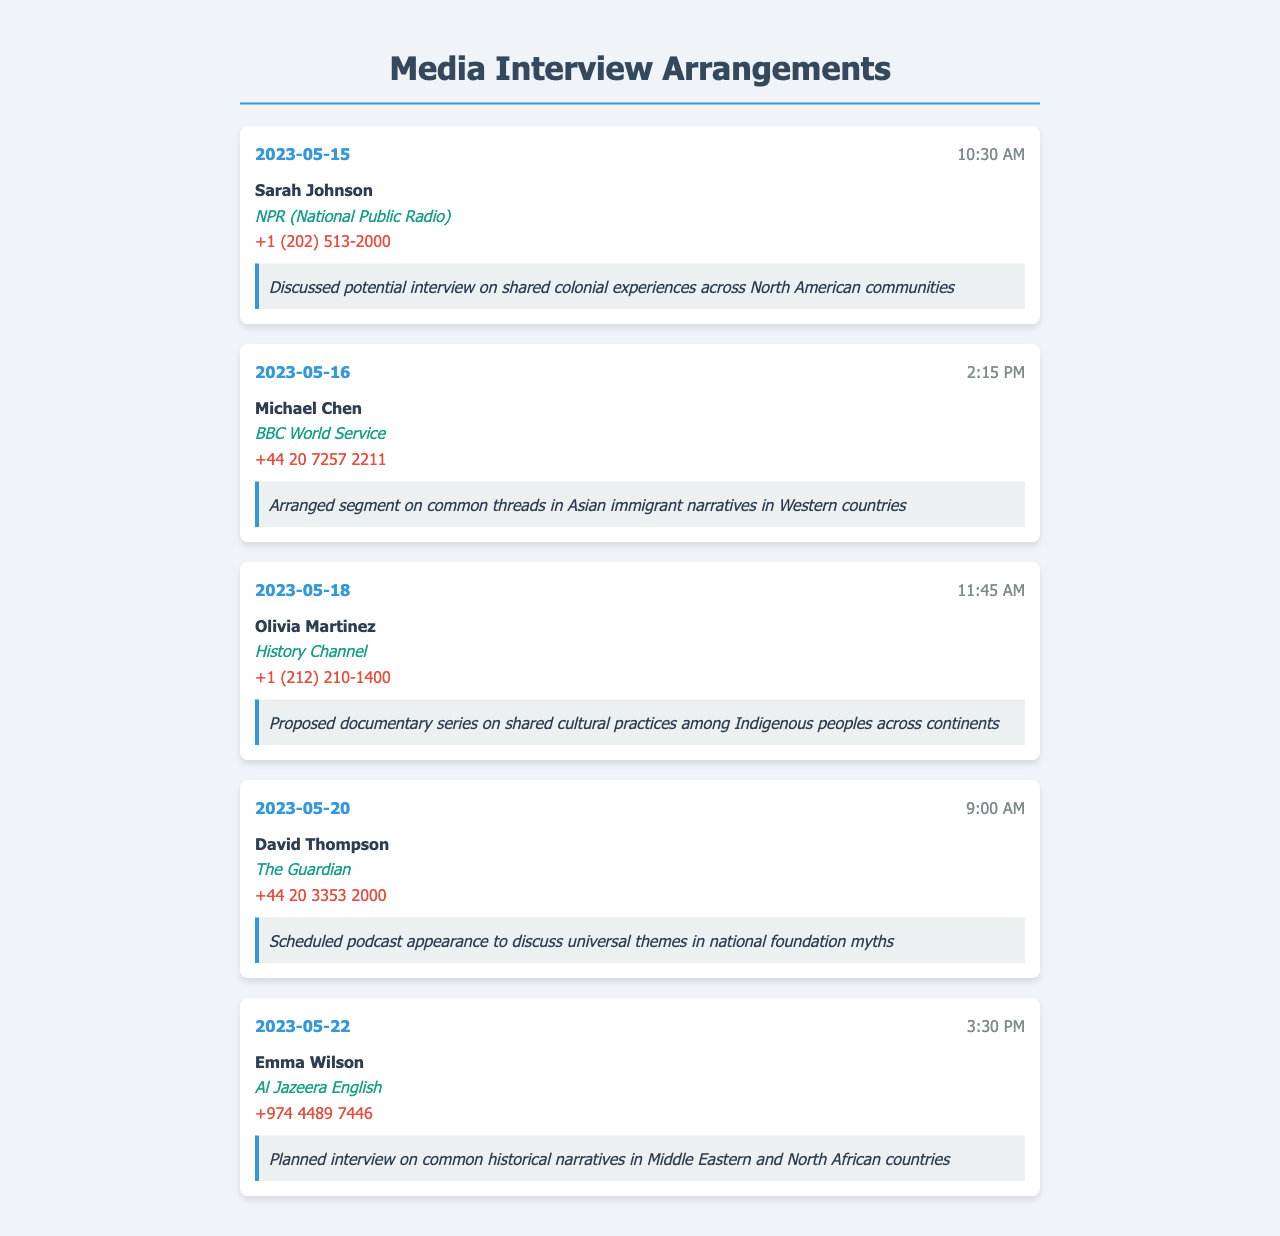What is the date of the first call? The date of the first call is mentioned in the document as May 15, 2023.
Answer: 2023-05-15 Who is the contact person for the interview with NPR? The contact person for the interview with NPR is mentioned as Sarah Johnson.
Answer: Sarah Johnson What organization is David Thompson affiliated with? The document states that David Thompson is affiliated with The Guardian.
Answer: The Guardian What was discussed in the call with Olivia Martinez? The notes for the call with Olivia Martinez indicate a proposal for a documentary series related to Indigenous peoples.
Answer: Proposed documentary series on shared cultural practices among Indigenous peoples across continents How many calls were recorded in total? The total number of calls recorded can be counted from the document, which shows five calls in total.
Answer: 5 What is the phone number for Al Jazeera English? The phone number for Al Jazeera English is listed in the document.
Answer: +974 4489 7446 Which media outlet discussed Asian immigrant narratives? The interview segment on common threads in Asian immigrant narratives was arranged with BBC World Service.
Answer: BBC World Service What common theme do the calls focus on? The calls focus on common historical narratives shared among diverse communities.
Answer: Common historical narratives 